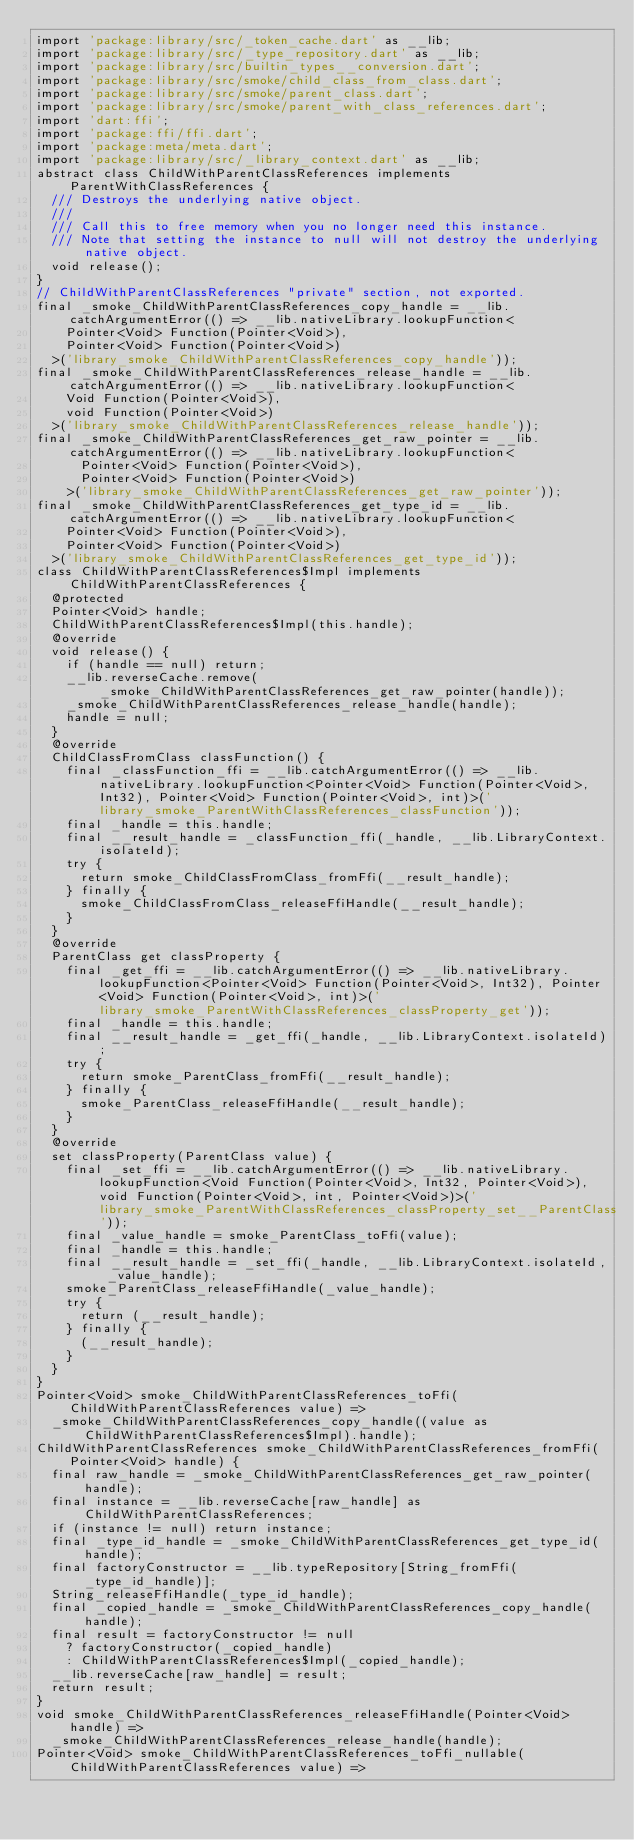<code> <loc_0><loc_0><loc_500><loc_500><_Dart_>import 'package:library/src/_token_cache.dart' as __lib;
import 'package:library/src/_type_repository.dart' as __lib;
import 'package:library/src/builtin_types__conversion.dart';
import 'package:library/src/smoke/child_class_from_class.dart';
import 'package:library/src/smoke/parent_class.dart';
import 'package:library/src/smoke/parent_with_class_references.dart';
import 'dart:ffi';
import 'package:ffi/ffi.dart';
import 'package:meta/meta.dart';
import 'package:library/src/_library_context.dart' as __lib;
abstract class ChildWithParentClassReferences implements ParentWithClassReferences {
  /// Destroys the underlying native object.
  ///
  /// Call this to free memory when you no longer need this instance.
  /// Note that setting the instance to null will not destroy the underlying native object.
  void release();
}
// ChildWithParentClassReferences "private" section, not exported.
final _smoke_ChildWithParentClassReferences_copy_handle = __lib.catchArgumentError(() => __lib.nativeLibrary.lookupFunction<
    Pointer<Void> Function(Pointer<Void>),
    Pointer<Void> Function(Pointer<Void>)
  >('library_smoke_ChildWithParentClassReferences_copy_handle'));
final _smoke_ChildWithParentClassReferences_release_handle = __lib.catchArgumentError(() => __lib.nativeLibrary.lookupFunction<
    Void Function(Pointer<Void>),
    void Function(Pointer<Void>)
  >('library_smoke_ChildWithParentClassReferences_release_handle'));
final _smoke_ChildWithParentClassReferences_get_raw_pointer = __lib.catchArgumentError(() => __lib.nativeLibrary.lookupFunction<
      Pointer<Void> Function(Pointer<Void>),
      Pointer<Void> Function(Pointer<Void>)
    >('library_smoke_ChildWithParentClassReferences_get_raw_pointer'));
final _smoke_ChildWithParentClassReferences_get_type_id = __lib.catchArgumentError(() => __lib.nativeLibrary.lookupFunction<
    Pointer<Void> Function(Pointer<Void>),
    Pointer<Void> Function(Pointer<Void>)
  >('library_smoke_ChildWithParentClassReferences_get_type_id'));
class ChildWithParentClassReferences$Impl implements ChildWithParentClassReferences {
  @protected
  Pointer<Void> handle;
  ChildWithParentClassReferences$Impl(this.handle);
  @override
  void release() {
    if (handle == null) return;
    __lib.reverseCache.remove(_smoke_ChildWithParentClassReferences_get_raw_pointer(handle));
    _smoke_ChildWithParentClassReferences_release_handle(handle);
    handle = null;
  }
  @override
  ChildClassFromClass classFunction() {
    final _classFunction_ffi = __lib.catchArgumentError(() => __lib.nativeLibrary.lookupFunction<Pointer<Void> Function(Pointer<Void>, Int32), Pointer<Void> Function(Pointer<Void>, int)>('library_smoke_ParentWithClassReferences_classFunction'));
    final _handle = this.handle;
    final __result_handle = _classFunction_ffi(_handle, __lib.LibraryContext.isolateId);
    try {
      return smoke_ChildClassFromClass_fromFfi(__result_handle);
    } finally {
      smoke_ChildClassFromClass_releaseFfiHandle(__result_handle);
    }
  }
  @override
  ParentClass get classProperty {
    final _get_ffi = __lib.catchArgumentError(() => __lib.nativeLibrary.lookupFunction<Pointer<Void> Function(Pointer<Void>, Int32), Pointer<Void> Function(Pointer<Void>, int)>('library_smoke_ParentWithClassReferences_classProperty_get'));
    final _handle = this.handle;
    final __result_handle = _get_ffi(_handle, __lib.LibraryContext.isolateId);
    try {
      return smoke_ParentClass_fromFfi(__result_handle);
    } finally {
      smoke_ParentClass_releaseFfiHandle(__result_handle);
    }
  }
  @override
  set classProperty(ParentClass value) {
    final _set_ffi = __lib.catchArgumentError(() => __lib.nativeLibrary.lookupFunction<Void Function(Pointer<Void>, Int32, Pointer<Void>), void Function(Pointer<Void>, int, Pointer<Void>)>('library_smoke_ParentWithClassReferences_classProperty_set__ParentClass'));
    final _value_handle = smoke_ParentClass_toFfi(value);
    final _handle = this.handle;
    final __result_handle = _set_ffi(_handle, __lib.LibraryContext.isolateId, _value_handle);
    smoke_ParentClass_releaseFfiHandle(_value_handle);
    try {
      return (__result_handle);
    } finally {
      (__result_handle);
    }
  }
}
Pointer<Void> smoke_ChildWithParentClassReferences_toFfi(ChildWithParentClassReferences value) =>
  _smoke_ChildWithParentClassReferences_copy_handle((value as ChildWithParentClassReferences$Impl).handle);
ChildWithParentClassReferences smoke_ChildWithParentClassReferences_fromFfi(Pointer<Void> handle) {
  final raw_handle = _smoke_ChildWithParentClassReferences_get_raw_pointer(handle);
  final instance = __lib.reverseCache[raw_handle] as ChildWithParentClassReferences;
  if (instance != null) return instance;
  final _type_id_handle = _smoke_ChildWithParentClassReferences_get_type_id(handle);
  final factoryConstructor = __lib.typeRepository[String_fromFfi(_type_id_handle)];
  String_releaseFfiHandle(_type_id_handle);
  final _copied_handle = _smoke_ChildWithParentClassReferences_copy_handle(handle);
  final result = factoryConstructor != null
    ? factoryConstructor(_copied_handle)
    : ChildWithParentClassReferences$Impl(_copied_handle);
  __lib.reverseCache[raw_handle] = result;
  return result;
}
void smoke_ChildWithParentClassReferences_releaseFfiHandle(Pointer<Void> handle) =>
  _smoke_ChildWithParentClassReferences_release_handle(handle);
Pointer<Void> smoke_ChildWithParentClassReferences_toFfi_nullable(ChildWithParentClassReferences value) =></code> 